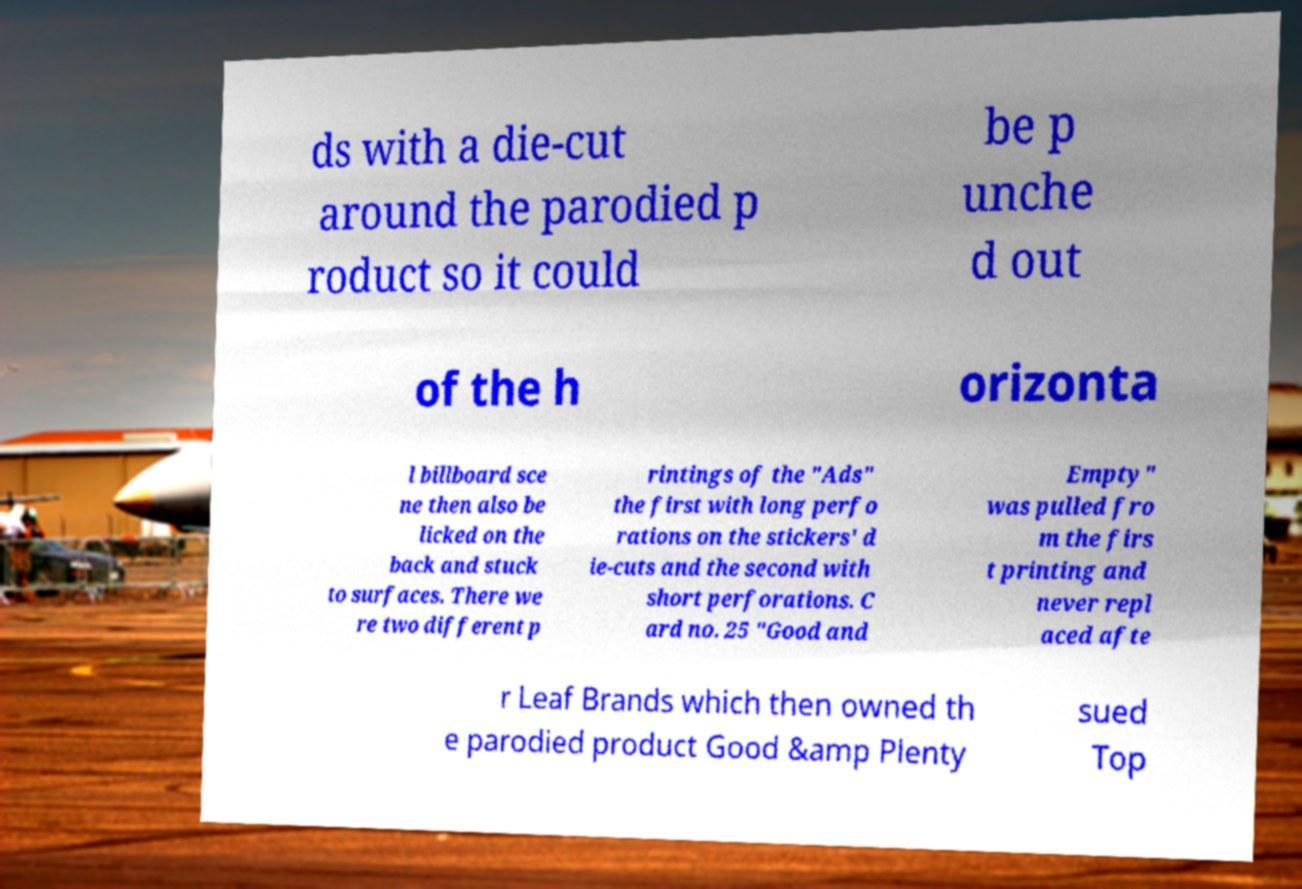For documentation purposes, I need the text within this image transcribed. Could you provide that? ds with a die-cut around the parodied p roduct so it could be p unche d out of the h orizonta l billboard sce ne then also be licked on the back and stuck to surfaces. There we re two different p rintings of the "Ads" the first with long perfo rations on the stickers' d ie-cuts and the second with short perforations. C ard no. 25 "Good and Empty" was pulled fro m the firs t printing and never repl aced afte r Leaf Brands which then owned th e parodied product Good &amp Plenty sued Top 